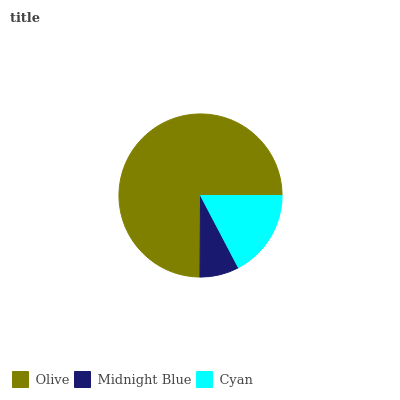Is Midnight Blue the minimum?
Answer yes or no. Yes. Is Olive the maximum?
Answer yes or no. Yes. Is Cyan the minimum?
Answer yes or no. No. Is Cyan the maximum?
Answer yes or no. No. Is Cyan greater than Midnight Blue?
Answer yes or no. Yes. Is Midnight Blue less than Cyan?
Answer yes or no. Yes. Is Midnight Blue greater than Cyan?
Answer yes or no. No. Is Cyan less than Midnight Blue?
Answer yes or no. No. Is Cyan the high median?
Answer yes or no. Yes. Is Cyan the low median?
Answer yes or no. Yes. Is Midnight Blue the high median?
Answer yes or no. No. Is Olive the low median?
Answer yes or no. No. 